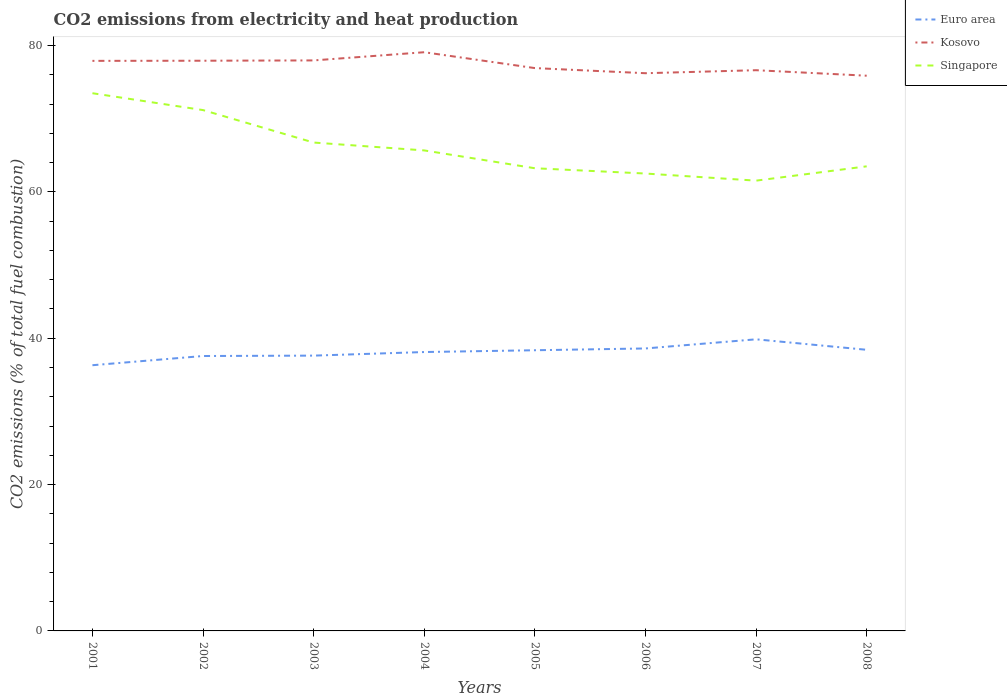How many different coloured lines are there?
Your answer should be very brief. 3. Does the line corresponding to Singapore intersect with the line corresponding to Euro area?
Give a very brief answer. No. Across all years, what is the maximum amount of CO2 emitted in Euro area?
Your response must be concise. 36.31. What is the total amount of CO2 emitted in Kosovo in the graph?
Offer a very short reply. 0.29. What is the difference between the highest and the second highest amount of CO2 emitted in Euro area?
Offer a very short reply. 3.54. What is the difference between the highest and the lowest amount of CO2 emitted in Kosovo?
Give a very brief answer. 4. How many lines are there?
Make the answer very short. 3. What is the difference between two consecutive major ticks on the Y-axis?
Your answer should be compact. 20. Does the graph contain grids?
Keep it short and to the point. No. How many legend labels are there?
Keep it short and to the point. 3. What is the title of the graph?
Keep it short and to the point. CO2 emissions from electricity and heat production. Does "Gambia, The" appear as one of the legend labels in the graph?
Provide a short and direct response. No. What is the label or title of the Y-axis?
Keep it short and to the point. CO2 emissions (% of total fuel combustion). What is the CO2 emissions (% of total fuel combustion) of Euro area in 2001?
Offer a very short reply. 36.31. What is the CO2 emissions (% of total fuel combustion) of Kosovo in 2001?
Provide a succinct answer. 77.9. What is the CO2 emissions (% of total fuel combustion) of Singapore in 2001?
Provide a short and direct response. 73.48. What is the CO2 emissions (% of total fuel combustion) in Euro area in 2002?
Keep it short and to the point. 37.57. What is the CO2 emissions (% of total fuel combustion) of Kosovo in 2002?
Provide a short and direct response. 77.92. What is the CO2 emissions (% of total fuel combustion) in Singapore in 2002?
Give a very brief answer. 71.17. What is the CO2 emissions (% of total fuel combustion) of Euro area in 2003?
Offer a very short reply. 37.62. What is the CO2 emissions (% of total fuel combustion) in Kosovo in 2003?
Provide a succinct answer. 77.96. What is the CO2 emissions (% of total fuel combustion) in Singapore in 2003?
Your answer should be compact. 66.74. What is the CO2 emissions (% of total fuel combustion) in Euro area in 2004?
Provide a short and direct response. 38.11. What is the CO2 emissions (% of total fuel combustion) in Kosovo in 2004?
Provide a succinct answer. 79.08. What is the CO2 emissions (% of total fuel combustion) in Singapore in 2004?
Offer a terse response. 65.66. What is the CO2 emissions (% of total fuel combustion) in Euro area in 2005?
Ensure brevity in your answer.  38.36. What is the CO2 emissions (% of total fuel combustion) in Kosovo in 2005?
Ensure brevity in your answer.  76.91. What is the CO2 emissions (% of total fuel combustion) of Singapore in 2005?
Your answer should be very brief. 63.23. What is the CO2 emissions (% of total fuel combustion) in Euro area in 2006?
Your answer should be very brief. 38.6. What is the CO2 emissions (% of total fuel combustion) of Kosovo in 2006?
Give a very brief answer. 76.21. What is the CO2 emissions (% of total fuel combustion) in Singapore in 2006?
Provide a short and direct response. 62.5. What is the CO2 emissions (% of total fuel combustion) of Euro area in 2007?
Your response must be concise. 39.85. What is the CO2 emissions (% of total fuel combustion) of Kosovo in 2007?
Keep it short and to the point. 76.62. What is the CO2 emissions (% of total fuel combustion) in Singapore in 2007?
Your answer should be very brief. 61.53. What is the CO2 emissions (% of total fuel combustion) in Euro area in 2008?
Offer a very short reply. 38.42. What is the CO2 emissions (% of total fuel combustion) in Kosovo in 2008?
Your response must be concise. 75.87. What is the CO2 emissions (% of total fuel combustion) of Singapore in 2008?
Offer a terse response. 63.49. Across all years, what is the maximum CO2 emissions (% of total fuel combustion) of Euro area?
Offer a terse response. 39.85. Across all years, what is the maximum CO2 emissions (% of total fuel combustion) of Kosovo?
Provide a short and direct response. 79.08. Across all years, what is the maximum CO2 emissions (% of total fuel combustion) in Singapore?
Keep it short and to the point. 73.48. Across all years, what is the minimum CO2 emissions (% of total fuel combustion) of Euro area?
Offer a very short reply. 36.31. Across all years, what is the minimum CO2 emissions (% of total fuel combustion) in Kosovo?
Offer a terse response. 75.87. Across all years, what is the minimum CO2 emissions (% of total fuel combustion) of Singapore?
Your response must be concise. 61.53. What is the total CO2 emissions (% of total fuel combustion) in Euro area in the graph?
Make the answer very short. 304.83. What is the total CO2 emissions (% of total fuel combustion) in Kosovo in the graph?
Keep it short and to the point. 618.48. What is the total CO2 emissions (% of total fuel combustion) of Singapore in the graph?
Keep it short and to the point. 527.8. What is the difference between the CO2 emissions (% of total fuel combustion) of Euro area in 2001 and that in 2002?
Offer a terse response. -1.26. What is the difference between the CO2 emissions (% of total fuel combustion) in Kosovo in 2001 and that in 2002?
Your answer should be very brief. -0.02. What is the difference between the CO2 emissions (% of total fuel combustion) in Singapore in 2001 and that in 2002?
Offer a very short reply. 2.3. What is the difference between the CO2 emissions (% of total fuel combustion) in Euro area in 2001 and that in 2003?
Offer a terse response. -1.31. What is the difference between the CO2 emissions (% of total fuel combustion) in Kosovo in 2001 and that in 2003?
Offer a very short reply. -0.06. What is the difference between the CO2 emissions (% of total fuel combustion) in Singapore in 2001 and that in 2003?
Make the answer very short. 6.74. What is the difference between the CO2 emissions (% of total fuel combustion) in Euro area in 2001 and that in 2004?
Provide a succinct answer. -1.8. What is the difference between the CO2 emissions (% of total fuel combustion) of Kosovo in 2001 and that in 2004?
Your answer should be compact. -1.18. What is the difference between the CO2 emissions (% of total fuel combustion) in Singapore in 2001 and that in 2004?
Offer a terse response. 7.82. What is the difference between the CO2 emissions (% of total fuel combustion) in Euro area in 2001 and that in 2005?
Offer a very short reply. -2.05. What is the difference between the CO2 emissions (% of total fuel combustion) of Kosovo in 2001 and that in 2005?
Ensure brevity in your answer.  0.99. What is the difference between the CO2 emissions (% of total fuel combustion) of Singapore in 2001 and that in 2005?
Keep it short and to the point. 10.25. What is the difference between the CO2 emissions (% of total fuel combustion) of Euro area in 2001 and that in 2006?
Your answer should be very brief. -2.29. What is the difference between the CO2 emissions (% of total fuel combustion) in Kosovo in 2001 and that in 2006?
Provide a succinct answer. 1.69. What is the difference between the CO2 emissions (% of total fuel combustion) of Singapore in 2001 and that in 2006?
Keep it short and to the point. 10.98. What is the difference between the CO2 emissions (% of total fuel combustion) of Euro area in 2001 and that in 2007?
Offer a terse response. -3.54. What is the difference between the CO2 emissions (% of total fuel combustion) of Kosovo in 2001 and that in 2007?
Give a very brief answer. 1.28. What is the difference between the CO2 emissions (% of total fuel combustion) in Singapore in 2001 and that in 2007?
Provide a succinct answer. 11.95. What is the difference between the CO2 emissions (% of total fuel combustion) in Euro area in 2001 and that in 2008?
Offer a very short reply. -2.11. What is the difference between the CO2 emissions (% of total fuel combustion) in Kosovo in 2001 and that in 2008?
Your response must be concise. 2.03. What is the difference between the CO2 emissions (% of total fuel combustion) in Singapore in 2001 and that in 2008?
Make the answer very short. 9.99. What is the difference between the CO2 emissions (% of total fuel combustion) in Euro area in 2002 and that in 2003?
Give a very brief answer. -0.05. What is the difference between the CO2 emissions (% of total fuel combustion) of Kosovo in 2002 and that in 2003?
Keep it short and to the point. -0.04. What is the difference between the CO2 emissions (% of total fuel combustion) of Singapore in 2002 and that in 2003?
Keep it short and to the point. 4.44. What is the difference between the CO2 emissions (% of total fuel combustion) in Euro area in 2002 and that in 2004?
Provide a short and direct response. -0.54. What is the difference between the CO2 emissions (% of total fuel combustion) in Kosovo in 2002 and that in 2004?
Offer a very short reply. -1.16. What is the difference between the CO2 emissions (% of total fuel combustion) in Singapore in 2002 and that in 2004?
Your answer should be compact. 5.51. What is the difference between the CO2 emissions (% of total fuel combustion) in Euro area in 2002 and that in 2005?
Give a very brief answer. -0.79. What is the difference between the CO2 emissions (% of total fuel combustion) of Singapore in 2002 and that in 2005?
Your answer should be compact. 7.95. What is the difference between the CO2 emissions (% of total fuel combustion) in Euro area in 2002 and that in 2006?
Offer a terse response. -1.03. What is the difference between the CO2 emissions (% of total fuel combustion) of Kosovo in 2002 and that in 2006?
Provide a short and direct response. 1.71. What is the difference between the CO2 emissions (% of total fuel combustion) of Singapore in 2002 and that in 2006?
Give a very brief answer. 8.67. What is the difference between the CO2 emissions (% of total fuel combustion) in Euro area in 2002 and that in 2007?
Your response must be concise. -2.28. What is the difference between the CO2 emissions (% of total fuel combustion) in Kosovo in 2002 and that in 2007?
Keep it short and to the point. 1.29. What is the difference between the CO2 emissions (% of total fuel combustion) of Singapore in 2002 and that in 2007?
Ensure brevity in your answer.  9.64. What is the difference between the CO2 emissions (% of total fuel combustion) of Euro area in 2002 and that in 2008?
Your answer should be compact. -0.85. What is the difference between the CO2 emissions (% of total fuel combustion) in Kosovo in 2002 and that in 2008?
Your answer should be compact. 2.05. What is the difference between the CO2 emissions (% of total fuel combustion) in Singapore in 2002 and that in 2008?
Your response must be concise. 7.69. What is the difference between the CO2 emissions (% of total fuel combustion) in Euro area in 2003 and that in 2004?
Your answer should be very brief. -0.49. What is the difference between the CO2 emissions (% of total fuel combustion) in Kosovo in 2003 and that in 2004?
Give a very brief answer. -1.12. What is the difference between the CO2 emissions (% of total fuel combustion) in Singapore in 2003 and that in 2004?
Your response must be concise. 1.08. What is the difference between the CO2 emissions (% of total fuel combustion) in Euro area in 2003 and that in 2005?
Give a very brief answer. -0.73. What is the difference between the CO2 emissions (% of total fuel combustion) of Kosovo in 2003 and that in 2005?
Ensure brevity in your answer.  1.05. What is the difference between the CO2 emissions (% of total fuel combustion) of Singapore in 2003 and that in 2005?
Keep it short and to the point. 3.51. What is the difference between the CO2 emissions (% of total fuel combustion) in Euro area in 2003 and that in 2006?
Offer a terse response. -0.98. What is the difference between the CO2 emissions (% of total fuel combustion) in Kosovo in 2003 and that in 2006?
Offer a terse response. 1.75. What is the difference between the CO2 emissions (% of total fuel combustion) of Singapore in 2003 and that in 2006?
Make the answer very short. 4.23. What is the difference between the CO2 emissions (% of total fuel combustion) in Euro area in 2003 and that in 2007?
Ensure brevity in your answer.  -2.23. What is the difference between the CO2 emissions (% of total fuel combustion) in Kosovo in 2003 and that in 2007?
Provide a succinct answer. 1.34. What is the difference between the CO2 emissions (% of total fuel combustion) in Singapore in 2003 and that in 2007?
Keep it short and to the point. 5.21. What is the difference between the CO2 emissions (% of total fuel combustion) in Euro area in 2003 and that in 2008?
Provide a succinct answer. -0.8. What is the difference between the CO2 emissions (% of total fuel combustion) of Kosovo in 2003 and that in 2008?
Make the answer very short. 2.09. What is the difference between the CO2 emissions (% of total fuel combustion) in Euro area in 2004 and that in 2005?
Offer a very short reply. -0.24. What is the difference between the CO2 emissions (% of total fuel combustion) in Kosovo in 2004 and that in 2005?
Give a very brief answer. 2.17. What is the difference between the CO2 emissions (% of total fuel combustion) in Singapore in 2004 and that in 2005?
Provide a succinct answer. 2.44. What is the difference between the CO2 emissions (% of total fuel combustion) of Euro area in 2004 and that in 2006?
Ensure brevity in your answer.  -0.49. What is the difference between the CO2 emissions (% of total fuel combustion) in Kosovo in 2004 and that in 2006?
Provide a short and direct response. 2.87. What is the difference between the CO2 emissions (% of total fuel combustion) of Singapore in 2004 and that in 2006?
Give a very brief answer. 3.16. What is the difference between the CO2 emissions (% of total fuel combustion) of Euro area in 2004 and that in 2007?
Your answer should be compact. -1.74. What is the difference between the CO2 emissions (% of total fuel combustion) in Kosovo in 2004 and that in 2007?
Make the answer very short. 2.46. What is the difference between the CO2 emissions (% of total fuel combustion) in Singapore in 2004 and that in 2007?
Your answer should be compact. 4.13. What is the difference between the CO2 emissions (% of total fuel combustion) of Euro area in 2004 and that in 2008?
Give a very brief answer. -0.31. What is the difference between the CO2 emissions (% of total fuel combustion) of Kosovo in 2004 and that in 2008?
Ensure brevity in your answer.  3.21. What is the difference between the CO2 emissions (% of total fuel combustion) in Singapore in 2004 and that in 2008?
Provide a succinct answer. 2.17. What is the difference between the CO2 emissions (% of total fuel combustion) in Euro area in 2005 and that in 2006?
Your answer should be very brief. -0.24. What is the difference between the CO2 emissions (% of total fuel combustion) in Kosovo in 2005 and that in 2006?
Your answer should be very brief. 0.7. What is the difference between the CO2 emissions (% of total fuel combustion) of Singapore in 2005 and that in 2006?
Your answer should be very brief. 0.72. What is the difference between the CO2 emissions (% of total fuel combustion) in Euro area in 2005 and that in 2007?
Offer a terse response. -1.49. What is the difference between the CO2 emissions (% of total fuel combustion) of Kosovo in 2005 and that in 2007?
Provide a short and direct response. 0.29. What is the difference between the CO2 emissions (% of total fuel combustion) in Singapore in 2005 and that in 2007?
Make the answer very short. 1.69. What is the difference between the CO2 emissions (% of total fuel combustion) of Euro area in 2005 and that in 2008?
Provide a short and direct response. -0.06. What is the difference between the CO2 emissions (% of total fuel combustion) of Singapore in 2005 and that in 2008?
Provide a short and direct response. -0.26. What is the difference between the CO2 emissions (% of total fuel combustion) in Euro area in 2006 and that in 2007?
Your answer should be very brief. -1.25. What is the difference between the CO2 emissions (% of total fuel combustion) of Kosovo in 2006 and that in 2007?
Offer a terse response. -0.41. What is the difference between the CO2 emissions (% of total fuel combustion) of Singapore in 2006 and that in 2007?
Offer a very short reply. 0.97. What is the difference between the CO2 emissions (% of total fuel combustion) of Euro area in 2006 and that in 2008?
Ensure brevity in your answer.  0.18. What is the difference between the CO2 emissions (% of total fuel combustion) in Kosovo in 2006 and that in 2008?
Keep it short and to the point. 0.34. What is the difference between the CO2 emissions (% of total fuel combustion) of Singapore in 2006 and that in 2008?
Offer a very short reply. -0.98. What is the difference between the CO2 emissions (% of total fuel combustion) of Euro area in 2007 and that in 2008?
Your answer should be compact. 1.43. What is the difference between the CO2 emissions (% of total fuel combustion) of Kosovo in 2007 and that in 2008?
Offer a terse response. 0.75. What is the difference between the CO2 emissions (% of total fuel combustion) of Singapore in 2007 and that in 2008?
Offer a very short reply. -1.96. What is the difference between the CO2 emissions (% of total fuel combustion) in Euro area in 2001 and the CO2 emissions (% of total fuel combustion) in Kosovo in 2002?
Provide a succinct answer. -41.61. What is the difference between the CO2 emissions (% of total fuel combustion) in Euro area in 2001 and the CO2 emissions (% of total fuel combustion) in Singapore in 2002?
Your response must be concise. -34.86. What is the difference between the CO2 emissions (% of total fuel combustion) of Kosovo in 2001 and the CO2 emissions (% of total fuel combustion) of Singapore in 2002?
Keep it short and to the point. 6.73. What is the difference between the CO2 emissions (% of total fuel combustion) of Euro area in 2001 and the CO2 emissions (% of total fuel combustion) of Kosovo in 2003?
Give a very brief answer. -41.65. What is the difference between the CO2 emissions (% of total fuel combustion) in Euro area in 2001 and the CO2 emissions (% of total fuel combustion) in Singapore in 2003?
Your response must be concise. -30.43. What is the difference between the CO2 emissions (% of total fuel combustion) in Kosovo in 2001 and the CO2 emissions (% of total fuel combustion) in Singapore in 2003?
Provide a short and direct response. 11.16. What is the difference between the CO2 emissions (% of total fuel combustion) of Euro area in 2001 and the CO2 emissions (% of total fuel combustion) of Kosovo in 2004?
Your answer should be compact. -42.77. What is the difference between the CO2 emissions (% of total fuel combustion) of Euro area in 2001 and the CO2 emissions (% of total fuel combustion) of Singapore in 2004?
Offer a very short reply. -29.35. What is the difference between the CO2 emissions (% of total fuel combustion) in Kosovo in 2001 and the CO2 emissions (% of total fuel combustion) in Singapore in 2004?
Keep it short and to the point. 12.24. What is the difference between the CO2 emissions (% of total fuel combustion) in Euro area in 2001 and the CO2 emissions (% of total fuel combustion) in Kosovo in 2005?
Provide a short and direct response. -40.6. What is the difference between the CO2 emissions (% of total fuel combustion) of Euro area in 2001 and the CO2 emissions (% of total fuel combustion) of Singapore in 2005?
Your response must be concise. -26.92. What is the difference between the CO2 emissions (% of total fuel combustion) in Kosovo in 2001 and the CO2 emissions (% of total fuel combustion) in Singapore in 2005?
Ensure brevity in your answer.  14.67. What is the difference between the CO2 emissions (% of total fuel combustion) of Euro area in 2001 and the CO2 emissions (% of total fuel combustion) of Kosovo in 2006?
Your answer should be very brief. -39.9. What is the difference between the CO2 emissions (% of total fuel combustion) in Euro area in 2001 and the CO2 emissions (% of total fuel combustion) in Singapore in 2006?
Your response must be concise. -26.19. What is the difference between the CO2 emissions (% of total fuel combustion) in Kosovo in 2001 and the CO2 emissions (% of total fuel combustion) in Singapore in 2006?
Make the answer very short. 15.4. What is the difference between the CO2 emissions (% of total fuel combustion) of Euro area in 2001 and the CO2 emissions (% of total fuel combustion) of Kosovo in 2007?
Keep it short and to the point. -40.31. What is the difference between the CO2 emissions (% of total fuel combustion) of Euro area in 2001 and the CO2 emissions (% of total fuel combustion) of Singapore in 2007?
Provide a succinct answer. -25.22. What is the difference between the CO2 emissions (% of total fuel combustion) in Kosovo in 2001 and the CO2 emissions (% of total fuel combustion) in Singapore in 2007?
Make the answer very short. 16.37. What is the difference between the CO2 emissions (% of total fuel combustion) in Euro area in 2001 and the CO2 emissions (% of total fuel combustion) in Kosovo in 2008?
Ensure brevity in your answer.  -39.56. What is the difference between the CO2 emissions (% of total fuel combustion) in Euro area in 2001 and the CO2 emissions (% of total fuel combustion) in Singapore in 2008?
Make the answer very short. -27.18. What is the difference between the CO2 emissions (% of total fuel combustion) in Kosovo in 2001 and the CO2 emissions (% of total fuel combustion) in Singapore in 2008?
Provide a short and direct response. 14.41. What is the difference between the CO2 emissions (% of total fuel combustion) of Euro area in 2002 and the CO2 emissions (% of total fuel combustion) of Kosovo in 2003?
Ensure brevity in your answer.  -40.39. What is the difference between the CO2 emissions (% of total fuel combustion) of Euro area in 2002 and the CO2 emissions (% of total fuel combustion) of Singapore in 2003?
Offer a terse response. -29.17. What is the difference between the CO2 emissions (% of total fuel combustion) in Kosovo in 2002 and the CO2 emissions (% of total fuel combustion) in Singapore in 2003?
Offer a very short reply. 11.18. What is the difference between the CO2 emissions (% of total fuel combustion) of Euro area in 2002 and the CO2 emissions (% of total fuel combustion) of Kosovo in 2004?
Ensure brevity in your answer.  -41.51. What is the difference between the CO2 emissions (% of total fuel combustion) of Euro area in 2002 and the CO2 emissions (% of total fuel combustion) of Singapore in 2004?
Provide a short and direct response. -28.09. What is the difference between the CO2 emissions (% of total fuel combustion) in Kosovo in 2002 and the CO2 emissions (% of total fuel combustion) in Singapore in 2004?
Keep it short and to the point. 12.26. What is the difference between the CO2 emissions (% of total fuel combustion) in Euro area in 2002 and the CO2 emissions (% of total fuel combustion) in Kosovo in 2005?
Keep it short and to the point. -39.34. What is the difference between the CO2 emissions (% of total fuel combustion) in Euro area in 2002 and the CO2 emissions (% of total fuel combustion) in Singapore in 2005?
Offer a very short reply. -25.66. What is the difference between the CO2 emissions (% of total fuel combustion) of Kosovo in 2002 and the CO2 emissions (% of total fuel combustion) of Singapore in 2005?
Your answer should be very brief. 14.69. What is the difference between the CO2 emissions (% of total fuel combustion) in Euro area in 2002 and the CO2 emissions (% of total fuel combustion) in Kosovo in 2006?
Ensure brevity in your answer.  -38.65. What is the difference between the CO2 emissions (% of total fuel combustion) of Euro area in 2002 and the CO2 emissions (% of total fuel combustion) of Singapore in 2006?
Ensure brevity in your answer.  -24.94. What is the difference between the CO2 emissions (% of total fuel combustion) in Kosovo in 2002 and the CO2 emissions (% of total fuel combustion) in Singapore in 2006?
Your answer should be compact. 15.42. What is the difference between the CO2 emissions (% of total fuel combustion) in Euro area in 2002 and the CO2 emissions (% of total fuel combustion) in Kosovo in 2007?
Your answer should be compact. -39.06. What is the difference between the CO2 emissions (% of total fuel combustion) in Euro area in 2002 and the CO2 emissions (% of total fuel combustion) in Singapore in 2007?
Ensure brevity in your answer.  -23.96. What is the difference between the CO2 emissions (% of total fuel combustion) in Kosovo in 2002 and the CO2 emissions (% of total fuel combustion) in Singapore in 2007?
Keep it short and to the point. 16.39. What is the difference between the CO2 emissions (% of total fuel combustion) in Euro area in 2002 and the CO2 emissions (% of total fuel combustion) in Kosovo in 2008?
Keep it short and to the point. -38.3. What is the difference between the CO2 emissions (% of total fuel combustion) in Euro area in 2002 and the CO2 emissions (% of total fuel combustion) in Singapore in 2008?
Give a very brief answer. -25.92. What is the difference between the CO2 emissions (% of total fuel combustion) of Kosovo in 2002 and the CO2 emissions (% of total fuel combustion) of Singapore in 2008?
Ensure brevity in your answer.  14.43. What is the difference between the CO2 emissions (% of total fuel combustion) in Euro area in 2003 and the CO2 emissions (% of total fuel combustion) in Kosovo in 2004?
Offer a terse response. -41.46. What is the difference between the CO2 emissions (% of total fuel combustion) of Euro area in 2003 and the CO2 emissions (% of total fuel combustion) of Singapore in 2004?
Ensure brevity in your answer.  -28.04. What is the difference between the CO2 emissions (% of total fuel combustion) in Kosovo in 2003 and the CO2 emissions (% of total fuel combustion) in Singapore in 2004?
Your answer should be compact. 12.3. What is the difference between the CO2 emissions (% of total fuel combustion) of Euro area in 2003 and the CO2 emissions (% of total fuel combustion) of Kosovo in 2005?
Ensure brevity in your answer.  -39.29. What is the difference between the CO2 emissions (% of total fuel combustion) in Euro area in 2003 and the CO2 emissions (% of total fuel combustion) in Singapore in 2005?
Ensure brevity in your answer.  -25.61. What is the difference between the CO2 emissions (% of total fuel combustion) in Kosovo in 2003 and the CO2 emissions (% of total fuel combustion) in Singapore in 2005?
Provide a succinct answer. 14.74. What is the difference between the CO2 emissions (% of total fuel combustion) of Euro area in 2003 and the CO2 emissions (% of total fuel combustion) of Kosovo in 2006?
Provide a succinct answer. -38.59. What is the difference between the CO2 emissions (% of total fuel combustion) in Euro area in 2003 and the CO2 emissions (% of total fuel combustion) in Singapore in 2006?
Give a very brief answer. -24.88. What is the difference between the CO2 emissions (% of total fuel combustion) in Kosovo in 2003 and the CO2 emissions (% of total fuel combustion) in Singapore in 2006?
Your answer should be very brief. 15.46. What is the difference between the CO2 emissions (% of total fuel combustion) of Euro area in 2003 and the CO2 emissions (% of total fuel combustion) of Kosovo in 2007?
Keep it short and to the point. -39. What is the difference between the CO2 emissions (% of total fuel combustion) of Euro area in 2003 and the CO2 emissions (% of total fuel combustion) of Singapore in 2007?
Provide a succinct answer. -23.91. What is the difference between the CO2 emissions (% of total fuel combustion) of Kosovo in 2003 and the CO2 emissions (% of total fuel combustion) of Singapore in 2007?
Your response must be concise. 16.43. What is the difference between the CO2 emissions (% of total fuel combustion) in Euro area in 2003 and the CO2 emissions (% of total fuel combustion) in Kosovo in 2008?
Offer a terse response. -38.25. What is the difference between the CO2 emissions (% of total fuel combustion) in Euro area in 2003 and the CO2 emissions (% of total fuel combustion) in Singapore in 2008?
Your response must be concise. -25.87. What is the difference between the CO2 emissions (% of total fuel combustion) of Kosovo in 2003 and the CO2 emissions (% of total fuel combustion) of Singapore in 2008?
Offer a terse response. 14.47. What is the difference between the CO2 emissions (% of total fuel combustion) in Euro area in 2004 and the CO2 emissions (% of total fuel combustion) in Kosovo in 2005?
Offer a very short reply. -38.8. What is the difference between the CO2 emissions (% of total fuel combustion) in Euro area in 2004 and the CO2 emissions (% of total fuel combustion) in Singapore in 2005?
Ensure brevity in your answer.  -25.11. What is the difference between the CO2 emissions (% of total fuel combustion) in Kosovo in 2004 and the CO2 emissions (% of total fuel combustion) in Singapore in 2005?
Ensure brevity in your answer.  15.85. What is the difference between the CO2 emissions (% of total fuel combustion) in Euro area in 2004 and the CO2 emissions (% of total fuel combustion) in Kosovo in 2006?
Offer a terse response. -38.1. What is the difference between the CO2 emissions (% of total fuel combustion) in Euro area in 2004 and the CO2 emissions (% of total fuel combustion) in Singapore in 2006?
Ensure brevity in your answer.  -24.39. What is the difference between the CO2 emissions (% of total fuel combustion) in Kosovo in 2004 and the CO2 emissions (% of total fuel combustion) in Singapore in 2006?
Your response must be concise. 16.58. What is the difference between the CO2 emissions (% of total fuel combustion) in Euro area in 2004 and the CO2 emissions (% of total fuel combustion) in Kosovo in 2007?
Give a very brief answer. -38.51. What is the difference between the CO2 emissions (% of total fuel combustion) of Euro area in 2004 and the CO2 emissions (% of total fuel combustion) of Singapore in 2007?
Offer a very short reply. -23.42. What is the difference between the CO2 emissions (% of total fuel combustion) in Kosovo in 2004 and the CO2 emissions (% of total fuel combustion) in Singapore in 2007?
Make the answer very short. 17.55. What is the difference between the CO2 emissions (% of total fuel combustion) of Euro area in 2004 and the CO2 emissions (% of total fuel combustion) of Kosovo in 2008?
Provide a succinct answer. -37.76. What is the difference between the CO2 emissions (% of total fuel combustion) of Euro area in 2004 and the CO2 emissions (% of total fuel combustion) of Singapore in 2008?
Give a very brief answer. -25.38. What is the difference between the CO2 emissions (% of total fuel combustion) of Kosovo in 2004 and the CO2 emissions (% of total fuel combustion) of Singapore in 2008?
Offer a terse response. 15.59. What is the difference between the CO2 emissions (% of total fuel combustion) in Euro area in 2005 and the CO2 emissions (% of total fuel combustion) in Kosovo in 2006?
Your answer should be very brief. -37.86. What is the difference between the CO2 emissions (% of total fuel combustion) of Euro area in 2005 and the CO2 emissions (% of total fuel combustion) of Singapore in 2006?
Offer a terse response. -24.15. What is the difference between the CO2 emissions (% of total fuel combustion) in Kosovo in 2005 and the CO2 emissions (% of total fuel combustion) in Singapore in 2006?
Ensure brevity in your answer.  14.41. What is the difference between the CO2 emissions (% of total fuel combustion) of Euro area in 2005 and the CO2 emissions (% of total fuel combustion) of Kosovo in 2007?
Keep it short and to the point. -38.27. What is the difference between the CO2 emissions (% of total fuel combustion) in Euro area in 2005 and the CO2 emissions (% of total fuel combustion) in Singapore in 2007?
Your response must be concise. -23.18. What is the difference between the CO2 emissions (% of total fuel combustion) of Kosovo in 2005 and the CO2 emissions (% of total fuel combustion) of Singapore in 2007?
Provide a succinct answer. 15.38. What is the difference between the CO2 emissions (% of total fuel combustion) of Euro area in 2005 and the CO2 emissions (% of total fuel combustion) of Kosovo in 2008?
Offer a terse response. -37.52. What is the difference between the CO2 emissions (% of total fuel combustion) of Euro area in 2005 and the CO2 emissions (% of total fuel combustion) of Singapore in 2008?
Keep it short and to the point. -25.13. What is the difference between the CO2 emissions (% of total fuel combustion) of Kosovo in 2005 and the CO2 emissions (% of total fuel combustion) of Singapore in 2008?
Provide a succinct answer. 13.42. What is the difference between the CO2 emissions (% of total fuel combustion) of Euro area in 2006 and the CO2 emissions (% of total fuel combustion) of Kosovo in 2007?
Make the answer very short. -38.02. What is the difference between the CO2 emissions (% of total fuel combustion) in Euro area in 2006 and the CO2 emissions (% of total fuel combustion) in Singapore in 2007?
Ensure brevity in your answer.  -22.93. What is the difference between the CO2 emissions (% of total fuel combustion) of Kosovo in 2006 and the CO2 emissions (% of total fuel combustion) of Singapore in 2007?
Your answer should be compact. 14.68. What is the difference between the CO2 emissions (% of total fuel combustion) of Euro area in 2006 and the CO2 emissions (% of total fuel combustion) of Kosovo in 2008?
Provide a short and direct response. -37.27. What is the difference between the CO2 emissions (% of total fuel combustion) in Euro area in 2006 and the CO2 emissions (% of total fuel combustion) in Singapore in 2008?
Your answer should be compact. -24.89. What is the difference between the CO2 emissions (% of total fuel combustion) of Kosovo in 2006 and the CO2 emissions (% of total fuel combustion) of Singapore in 2008?
Your response must be concise. 12.72. What is the difference between the CO2 emissions (% of total fuel combustion) of Euro area in 2007 and the CO2 emissions (% of total fuel combustion) of Kosovo in 2008?
Your answer should be compact. -36.02. What is the difference between the CO2 emissions (% of total fuel combustion) of Euro area in 2007 and the CO2 emissions (% of total fuel combustion) of Singapore in 2008?
Your response must be concise. -23.64. What is the difference between the CO2 emissions (% of total fuel combustion) in Kosovo in 2007 and the CO2 emissions (% of total fuel combustion) in Singapore in 2008?
Give a very brief answer. 13.14. What is the average CO2 emissions (% of total fuel combustion) in Euro area per year?
Offer a very short reply. 38.1. What is the average CO2 emissions (% of total fuel combustion) in Kosovo per year?
Give a very brief answer. 77.31. What is the average CO2 emissions (% of total fuel combustion) in Singapore per year?
Offer a terse response. 65.97. In the year 2001, what is the difference between the CO2 emissions (% of total fuel combustion) of Euro area and CO2 emissions (% of total fuel combustion) of Kosovo?
Offer a very short reply. -41.59. In the year 2001, what is the difference between the CO2 emissions (% of total fuel combustion) of Euro area and CO2 emissions (% of total fuel combustion) of Singapore?
Offer a terse response. -37.17. In the year 2001, what is the difference between the CO2 emissions (% of total fuel combustion) in Kosovo and CO2 emissions (% of total fuel combustion) in Singapore?
Offer a very short reply. 4.42. In the year 2002, what is the difference between the CO2 emissions (% of total fuel combustion) in Euro area and CO2 emissions (% of total fuel combustion) in Kosovo?
Your response must be concise. -40.35. In the year 2002, what is the difference between the CO2 emissions (% of total fuel combustion) of Euro area and CO2 emissions (% of total fuel combustion) of Singapore?
Offer a very short reply. -33.61. In the year 2002, what is the difference between the CO2 emissions (% of total fuel combustion) in Kosovo and CO2 emissions (% of total fuel combustion) in Singapore?
Provide a succinct answer. 6.74. In the year 2003, what is the difference between the CO2 emissions (% of total fuel combustion) of Euro area and CO2 emissions (% of total fuel combustion) of Kosovo?
Make the answer very short. -40.34. In the year 2003, what is the difference between the CO2 emissions (% of total fuel combustion) in Euro area and CO2 emissions (% of total fuel combustion) in Singapore?
Make the answer very short. -29.12. In the year 2003, what is the difference between the CO2 emissions (% of total fuel combustion) in Kosovo and CO2 emissions (% of total fuel combustion) in Singapore?
Give a very brief answer. 11.22. In the year 2004, what is the difference between the CO2 emissions (% of total fuel combustion) in Euro area and CO2 emissions (% of total fuel combustion) in Kosovo?
Make the answer very short. -40.97. In the year 2004, what is the difference between the CO2 emissions (% of total fuel combustion) of Euro area and CO2 emissions (% of total fuel combustion) of Singapore?
Offer a very short reply. -27.55. In the year 2004, what is the difference between the CO2 emissions (% of total fuel combustion) of Kosovo and CO2 emissions (% of total fuel combustion) of Singapore?
Your response must be concise. 13.42. In the year 2005, what is the difference between the CO2 emissions (% of total fuel combustion) of Euro area and CO2 emissions (% of total fuel combustion) of Kosovo?
Your response must be concise. -38.56. In the year 2005, what is the difference between the CO2 emissions (% of total fuel combustion) of Euro area and CO2 emissions (% of total fuel combustion) of Singapore?
Your answer should be very brief. -24.87. In the year 2005, what is the difference between the CO2 emissions (% of total fuel combustion) in Kosovo and CO2 emissions (% of total fuel combustion) in Singapore?
Give a very brief answer. 13.69. In the year 2006, what is the difference between the CO2 emissions (% of total fuel combustion) in Euro area and CO2 emissions (% of total fuel combustion) in Kosovo?
Provide a short and direct response. -37.61. In the year 2006, what is the difference between the CO2 emissions (% of total fuel combustion) of Euro area and CO2 emissions (% of total fuel combustion) of Singapore?
Offer a terse response. -23.9. In the year 2006, what is the difference between the CO2 emissions (% of total fuel combustion) in Kosovo and CO2 emissions (% of total fuel combustion) in Singapore?
Keep it short and to the point. 13.71. In the year 2007, what is the difference between the CO2 emissions (% of total fuel combustion) of Euro area and CO2 emissions (% of total fuel combustion) of Kosovo?
Provide a short and direct response. -36.77. In the year 2007, what is the difference between the CO2 emissions (% of total fuel combustion) in Euro area and CO2 emissions (% of total fuel combustion) in Singapore?
Make the answer very short. -21.68. In the year 2007, what is the difference between the CO2 emissions (% of total fuel combustion) of Kosovo and CO2 emissions (% of total fuel combustion) of Singapore?
Provide a short and direct response. 15.09. In the year 2008, what is the difference between the CO2 emissions (% of total fuel combustion) of Euro area and CO2 emissions (% of total fuel combustion) of Kosovo?
Your response must be concise. -37.46. In the year 2008, what is the difference between the CO2 emissions (% of total fuel combustion) in Euro area and CO2 emissions (% of total fuel combustion) in Singapore?
Keep it short and to the point. -25.07. In the year 2008, what is the difference between the CO2 emissions (% of total fuel combustion) in Kosovo and CO2 emissions (% of total fuel combustion) in Singapore?
Provide a succinct answer. 12.38. What is the ratio of the CO2 emissions (% of total fuel combustion) of Euro area in 2001 to that in 2002?
Make the answer very short. 0.97. What is the ratio of the CO2 emissions (% of total fuel combustion) of Singapore in 2001 to that in 2002?
Your answer should be very brief. 1.03. What is the ratio of the CO2 emissions (% of total fuel combustion) of Euro area in 2001 to that in 2003?
Offer a terse response. 0.97. What is the ratio of the CO2 emissions (% of total fuel combustion) in Singapore in 2001 to that in 2003?
Your answer should be compact. 1.1. What is the ratio of the CO2 emissions (% of total fuel combustion) of Euro area in 2001 to that in 2004?
Your answer should be compact. 0.95. What is the ratio of the CO2 emissions (% of total fuel combustion) of Kosovo in 2001 to that in 2004?
Ensure brevity in your answer.  0.99. What is the ratio of the CO2 emissions (% of total fuel combustion) of Singapore in 2001 to that in 2004?
Ensure brevity in your answer.  1.12. What is the ratio of the CO2 emissions (% of total fuel combustion) of Euro area in 2001 to that in 2005?
Provide a short and direct response. 0.95. What is the ratio of the CO2 emissions (% of total fuel combustion) of Kosovo in 2001 to that in 2005?
Offer a terse response. 1.01. What is the ratio of the CO2 emissions (% of total fuel combustion) of Singapore in 2001 to that in 2005?
Your response must be concise. 1.16. What is the ratio of the CO2 emissions (% of total fuel combustion) of Euro area in 2001 to that in 2006?
Provide a succinct answer. 0.94. What is the ratio of the CO2 emissions (% of total fuel combustion) in Kosovo in 2001 to that in 2006?
Ensure brevity in your answer.  1.02. What is the ratio of the CO2 emissions (% of total fuel combustion) in Singapore in 2001 to that in 2006?
Make the answer very short. 1.18. What is the ratio of the CO2 emissions (% of total fuel combustion) in Euro area in 2001 to that in 2007?
Keep it short and to the point. 0.91. What is the ratio of the CO2 emissions (% of total fuel combustion) of Kosovo in 2001 to that in 2007?
Your answer should be compact. 1.02. What is the ratio of the CO2 emissions (% of total fuel combustion) in Singapore in 2001 to that in 2007?
Ensure brevity in your answer.  1.19. What is the ratio of the CO2 emissions (% of total fuel combustion) of Euro area in 2001 to that in 2008?
Your answer should be compact. 0.95. What is the ratio of the CO2 emissions (% of total fuel combustion) of Kosovo in 2001 to that in 2008?
Your answer should be compact. 1.03. What is the ratio of the CO2 emissions (% of total fuel combustion) in Singapore in 2001 to that in 2008?
Your answer should be compact. 1.16. What is the ratio of the CO2 emissions (% of total fuel combustion) in Kosovo in 2002 to that in 2003?
Give a very brief answer. 1. What is the ratio of the CO2 emissions (% of total fuel combustion) of Singapore in 2002 to that in 2003?
Your response must be concise. 1.07. What is the ratio of the CO2 emissions (% of total fuel combustion) in Euro area in 2002 to that in 2004?
Your answer should be very brief. 0.99. What is the ratio of the CO2 emissions (% of total fuel combustion) in Kosovo in 2002 to that in 2004?
Give a very brief answer. 0.99. What is the ratio of the CO2 emissions (% of total fuel combustion) in Singapore in 2002 to that in 2004?
Your answer should be very brief. 1.08. What is the ratio of the CO2 emissions (% of total fuel combustion) in Euro area in 2002 to that in 2005?
Offer a very short reply. 0.98. What is the ratio of the CO2 emissions (% of total fuel combustion) in Kosovo in 2002 to that in 2005?
Make the answer very short. 1.01. What is the ratio of the CO2 emissions (% of total fuel combustion) of Singapore in 2002 to that in 2005?
Your answer should be compact. 1.13. What is the ratio of the CO2 emissions (% of total fuel combustion) of Euro area in 2002 to that in 2006?
Offer a very short reply. 0.97. What is the ratio of the CO2 emissions (% of total fuel combustion) of Kosovo in 2002 to that in 2006?
Provide a short and direct response. 1.02. What is the ratio of the CO2 emissions (% of total fuel combustion) in Singapore in 2002 to that in 2006?
Give a very brief answer. 1.14. What is the ratio of the CO2 emissions (% of total fuel combustion) in Euro area in 2002 to that in 2007?
Keep it short and to the point. 0.94. What is the ratio of the CO2 emissions (% of total fuel combustion) in Kosovo in 2002 to that in 2007?
Your answer should be very brief. 1.02. What is the ratio of the CO2 emissions (% of total fuel combustion) in Singapore in 2002 to that in 2007?
Provide a short and direct response. 1.16. What is the ratio of the CO2 emissions (% of total fuel combustion) in Euro area in 2002 to that in 2008?
Give a very brief answer. 0.98. What is the ratio of the CO2 emissions (% of total fuel combustion) of Singapore in 2002 to that in 2008?
Provide a short and direct response. 1.12. What is the ratio of the CO2 emissions (% of total fuel combustion) of Euro area in 2003 to that in 2004?
Make the answer very short. 0.99. What is the ratio of the CO2 emissions (% of total fuel combustion) in Kosovo in 2003 to that in 2004?
Your answer should be compact. 0.99. What is the ratio of the CO2 emissions (% of total fuel combustion) of Singapore in 2003 to that in 2004?
Ensure brevity in your answer.  1.02. What is the ratio of the CO2 emissions (% of total fuel combustion) in Euro area in 2003 to that in 2005?
Your answer should be very brief. 0.98. What is the ratio of the CO2 emissions (% of total fuel combustion) of Kosovo in 2003 to that in 2005?
Give a very brief answer. 1.01. What is the ratio of the CO2 emissions (% of total fuel combustion) of Singapore in 2003 to that in 2005?
Your answer should be very brief. 1.06. What is the ratio of the CO2 emissions (% of total fuel combustion) in Euro area in 2003 to that in 2006?
Offer a terse response. 0.97. What is the ratio of the CO2 emissions (% of total fuel combustion) of Kosovo in 2003 to that in 2006?
Offer a terse response. 1.02. What is the ratio of the CO2 emissions (% of total fuel combustion) in Singapore in 2003 to that in 2006?
Make the answer very short. 1.07. What is the ratio of the CO2 emissions (% of total fuel combustion) of Euro area in 2003 to that in 2007?
Ensure brevity in your answer.  0.94. What is the ratio of the CO2 emissions (% of total fuel combustion) of Kosovo in 2003 to that in 2007?
Give a very brief answer. 1.02. What is the ratio of the CO2 emissions (% of total fuel combustion) of Singapore in 2003 to that in 2007?
Keep it short and to the point. 1.08. What is the ratio of the CO2 emissions (% of total fuel combustion) in Euro area in 2003 to that in 2008?
Your answer should be compact. 0.98. What is the ratio of the CO2 emissions (% of total fuel combustion) of Kosovo in 2003 to that in 2008?
Your answer should be very brief. 1.03. What is the ratio of the CO2 emissions (% of total fuel combustion) in Singapore in 2003 to that in 2008?
Give a very brief answer. 1.05. What is the ratio of the CO2 emissions (% of total fuel combustion) of Kosovo in 2004 to that in 2005?
Your answer should be very brief. 1.03. What is the ratio of the CO2 emissions (% of total fuel combustion) of Singapore in 2004 to that in 2005?
Your answer should be very brief. 1.04. What is the ratio of the CO2 emissions (% of total fuel combustion) of Euro area in 2004 to that in 2006?
Provide a succinct answer. 0.99. What is the ratio of the CO2 emissions (% of total fuel combustion) in Kosovo in 2004 to that in 2006?
Provide a succinct answer. 1.04. What is the ratio of the CO2 emissions (% of total fuel combustion) in Singapore in 2004 to that in 2006?
Ensure brevity in your answer.  1.05. What is the ratio of the CO2 emissions (% of total fuel combustion) in Euro area in 2004 to that in 2007?
Offer a terse response. 0.96. What is the ratio of the CO2 emissions (% of total fuel combustion) of Kosovo in 2004 to that in 2007?
Give a very brief answer. 1.03. What is the ratio of the CO2 emissions (% of total fuel combustion) in Singapore in 2004 to that in 2007?
Your answer should be compact. 1.07. What is the ratio of the CO2 emissions (% of total fuel combustion) of Euro area in 2004 to that in 2008?
Make the answer very short. 0.99. What is the ratio of the CO2 emissions (% of total fuel combustion) in Kosovo in 2004 to that in 2008?
Your answer should be very brief. 1.04. What is the ratio of the CO2 emissions (% of total fuel combustion) in Singapore in 2004 to that in 2008?
Keep it short and to the point. 1.03. What is the ratio of the CO2 emissions (% of total fuel combustion) of Kosovo in 2005 to that in 2006?
Make the answer very short. 1.01. What is the ratio of the CO2 emissions (% of total fuel combustion) of Singapore in 2005 to that in 2006?
Your response must be concise. 1.01. What is the ratio of the CO2 emissions (% of total fuel combustion) of Euro area in 2005 to that in 2007?
Ensure brevity in your answer.  0.96. What is the ratio of the CO2 emissions (% of total fuel combustion) of Singapore in 2005 to that in 2007?
Your answer should be very brief. 1.03. What is the ratio of the CO2 emissions (% of total fuel combustion) of Euro area in 2005 to that in 2008?
Provide a succinct answer. 1. What is the ratio of the CO2 emissions (% of total fuel combustion) of Kosovo in 2005 to that in 2008?
Ensure brevity in your answer.  1.01. What is the ratio of the CO2 emissions (% of total fuel combustion) in Euro area in 2006 to that in 2007?
Your answer should be compact. 0.97. What is the ratio of the CO2 emissions (% of total fuel combustion) in Singapore in 2006 to that in 2007?
Your answer should be compact. 1.02. What is the ratio of the CO2 emissions (% of total fuel combustion) of Euro area in 2006 to that in 2008?
Your answer should be compact. 1. What is the ratio of the CO2 emissions (% of total fuel combustion) of Kosovo in 2006 to that in 2008?
Ensure brevity in your answer.  1. What is the ratio of the CO2 emissions (% of total fuel combustion) in Singapore in 2006 to that in 2008?
Provide a short and direct response. 0.98. What is the ratio of the CO2 emissions (% of total fuel combustion) of Euro area in 2007 to that in 2008?
Offer a very short reply. 1.04. What is the ratio of the CO2 emissions (% of total fuel combustion) in Kosovo in 2007 to that in 2008?
Provide a succinct answer. 1.01. What is the ratio of the CO2 emissions (% of total fuel combustion) of Singapore in 2007 to that in 2008?
Provide a succinct answer. 0.97. What is the difference between the highest and the second highest CO2 emissions (% of total fuel combustion) of Euro area?
Offer a terse response. 1.25. What is the difference between the highest and the second highest CO2 emissions (% of total fuel combustion) of Kosovo?
Offer a very short reply. 1.12. What is the difference between the highest and the second highest CO2 emissions (% of total fuel combustion) in Singapore?
Provide a short and direct response. 2.3. What is the difference between the highest and the lowest CO2 emissions (% of total fuel combustion) in Euro area?
Offer a terse response. 3.54. What is the difference between the highest and the lowest CO2 emissions (% of total fuel combustion) of Kosovo?
Offer a very short reply. 3.21. What is the difference between the highest and the lowest CO2 emissions (% of total fuel combustion) of Singapore?
Provide a succinct answer. 11.95. 